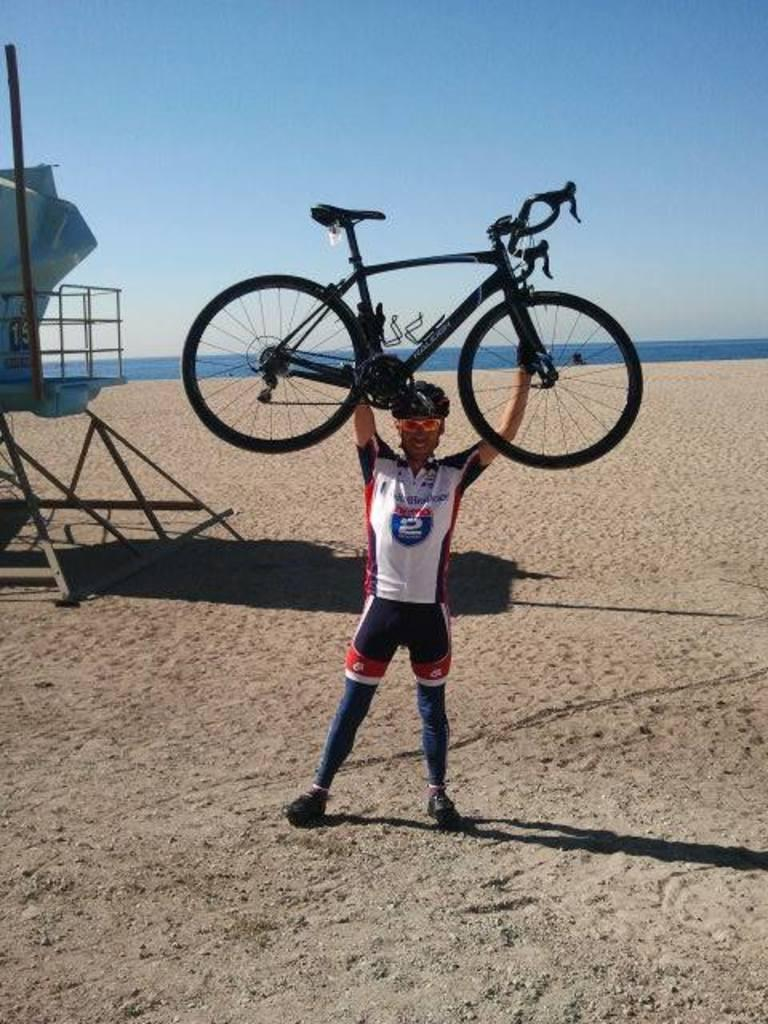Provide a one-sentence caption for the provided image. A man with the number 2 on his shirt is holding a bike over his head. 